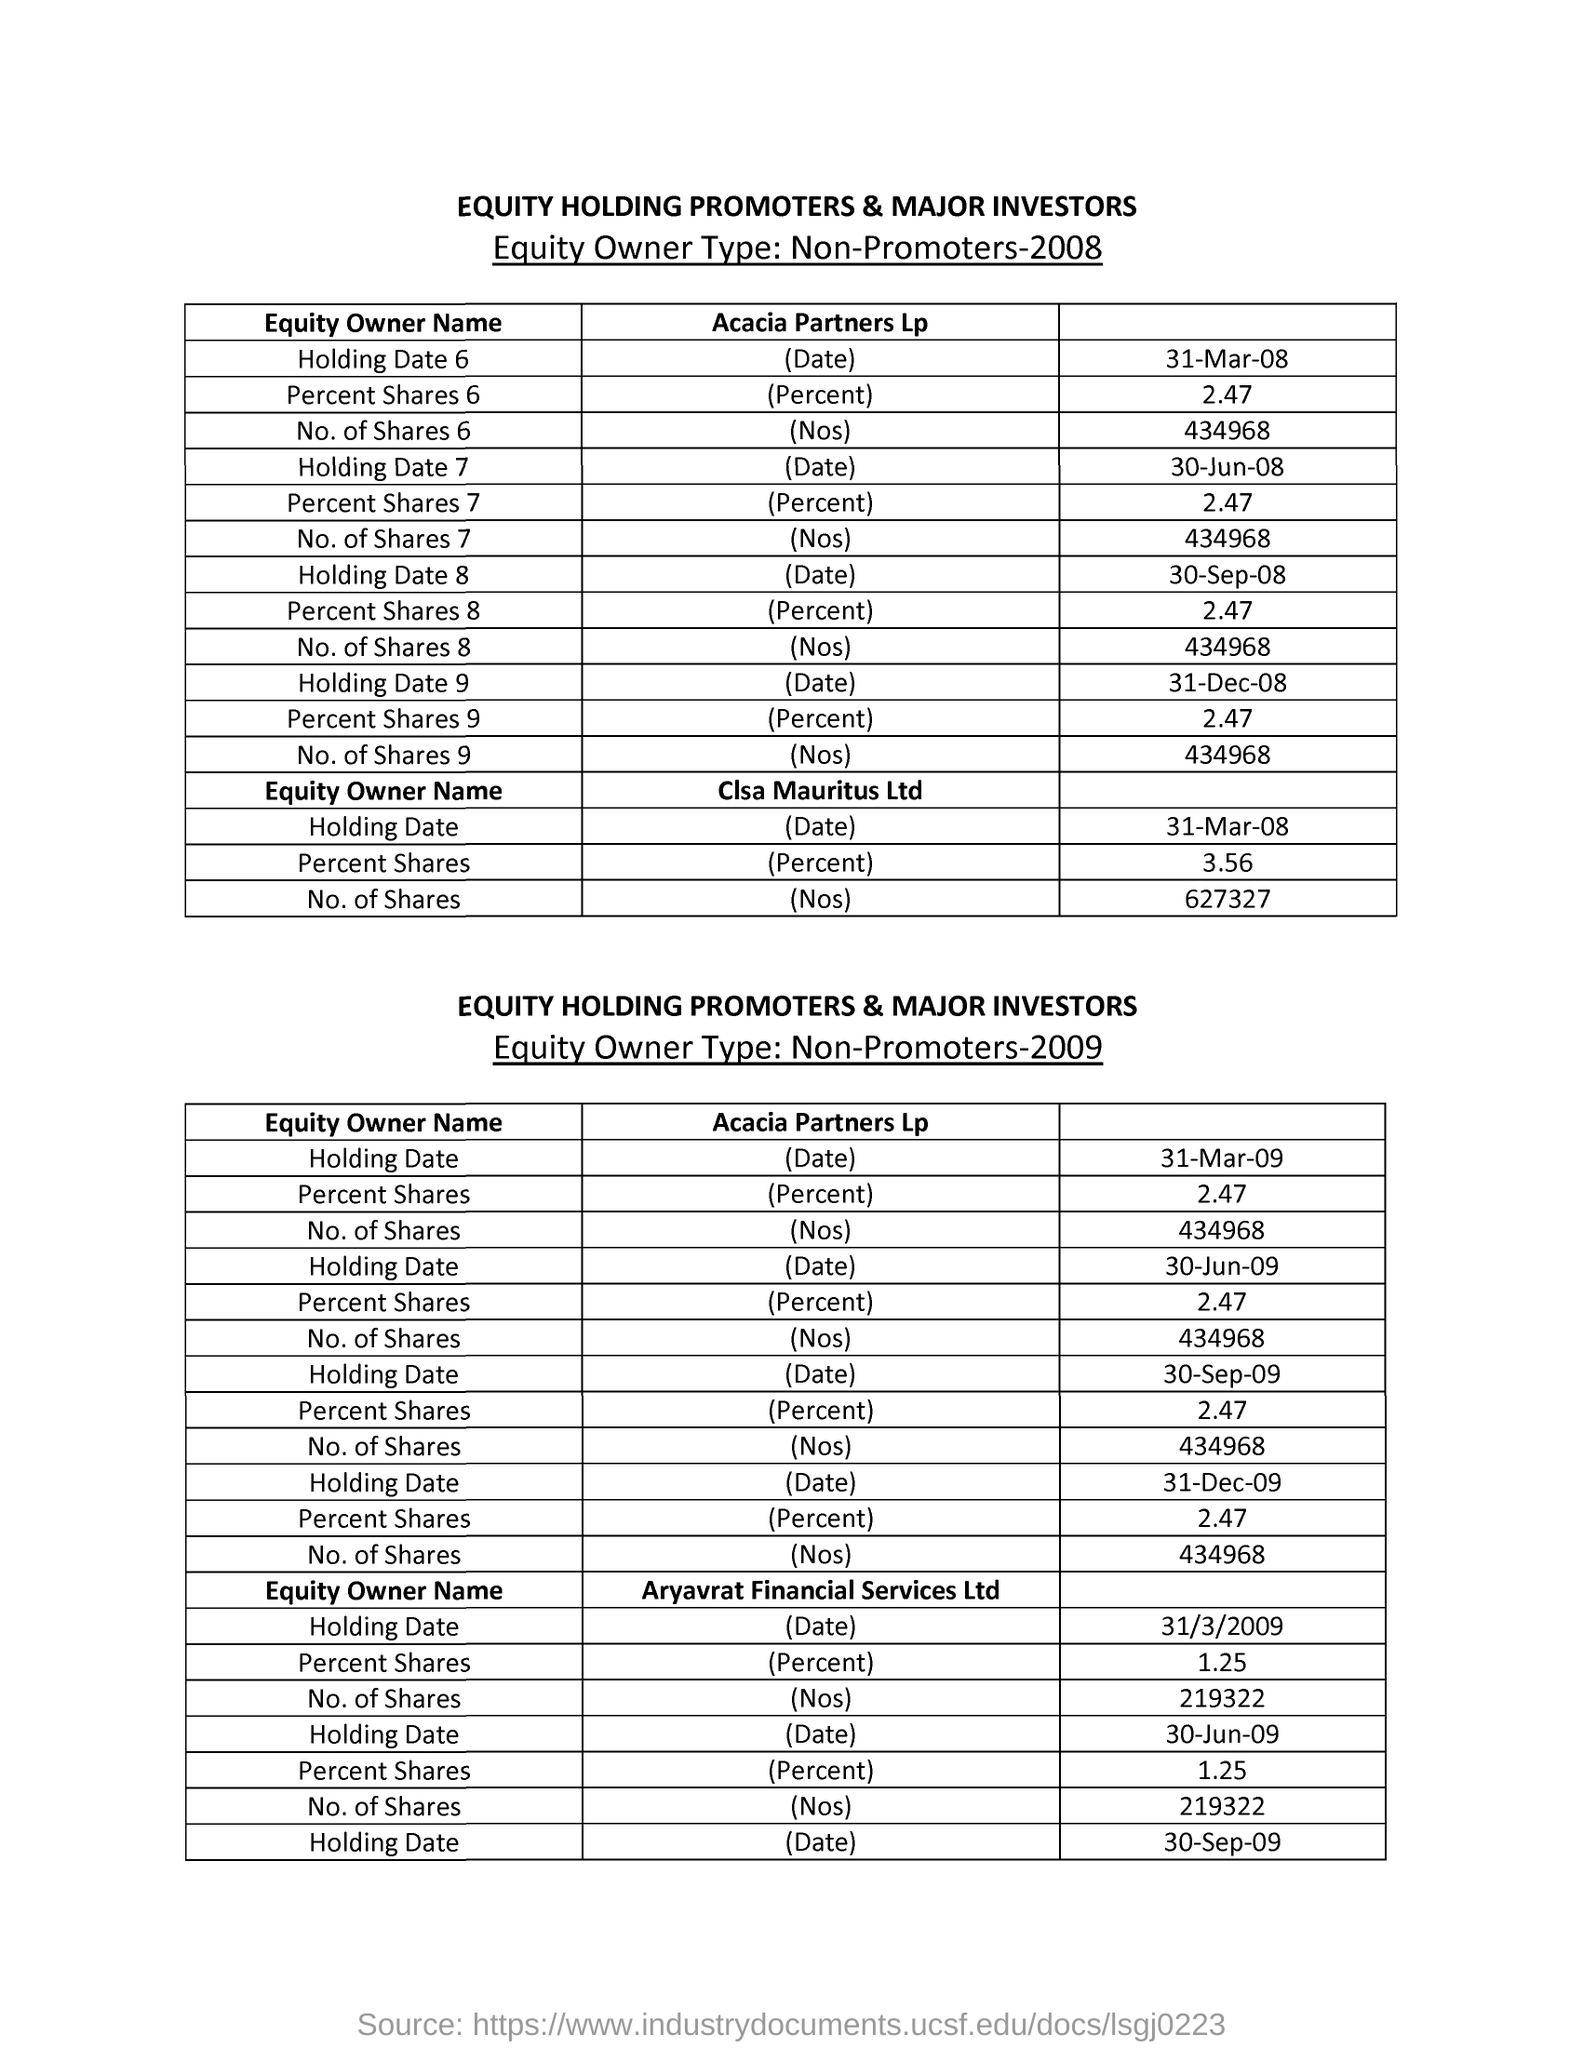What is the Holding Date 6 for Acacia Partners Lp in the year 2008?
Provide a short and direct response. 31-Mar-08. What is the Percent Shares 6 for Acacia Partners Lp in the year 2008?
Make the answer very short. 2.47. What is the Holding Date for Clsa Mauritus Ltd in the year 2008?
Offer a terse response. 31-Mar-08. What is the Percent Shares for Clsa Mauritus Ltd in the year 2008?
Your response must be concise. 3.56. What is the No. of shares for Clsa Maauritus Ltd  in the year 2008?
Ensure brevity in your answer.  627327. 